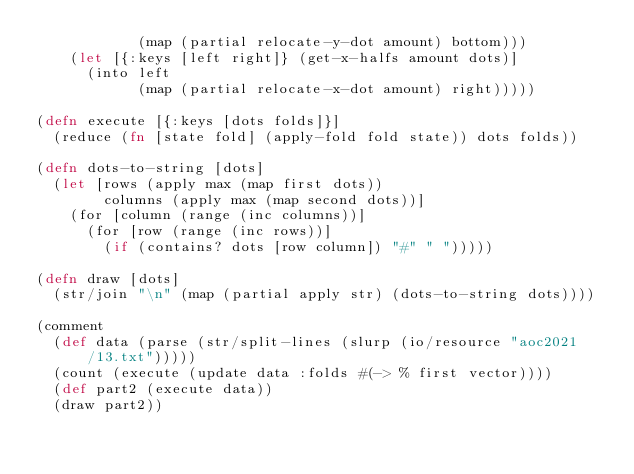<code> <loc_0><loc_0><loc_500><loc_500><_Clojure_>            (map (partial relocate-y-dot amount) bottom)))
    (let [{:keys [left right]} (get-x-halfs amount dots)]
      (into left
            (map (partial relocate-x-dot amount) right)))))

(defn execute [{:keys [dots folds]}]
  (reduce (fn [state fold] (apply-fold fold state)) dots folds))

(defn dots-to-string [dots]
  (let [rows (apply max (map first dots))
        columns (apply max (map second dots))]
    (for [column (range (inc columns))]
      (for [row (range (inc rows))]
        (if (contains? dots [row column]) "#" " ")))))

(defn draw [dots]
  (str/join "\n" (map (partial apply str) (dots-to-string dots))))

(comment
  (def data (parse (str/split-lines (slurp (io/resource "aoc2021/13.txt")))))
  (count (execute (update data :folds #(-> % first vector))))
  (def part2 (execute data))
  (draw part2))
</code> 